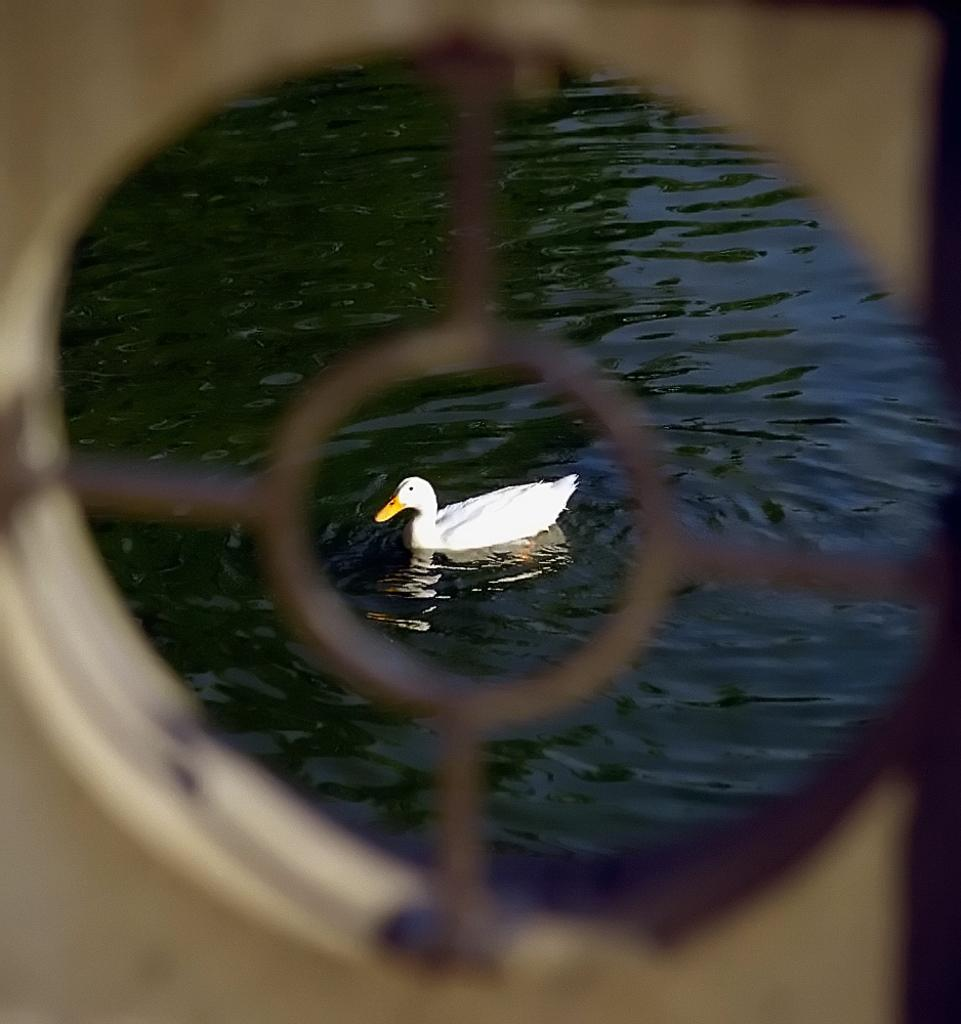What type of animal is in the image? There is a white duck in the image. Where is the duck located? The duck is on the water. What type of road is visible in the image? There is no road visible in the image; it features a white duck on the water. What type of meat is being prepared in the image? There is no meat preparation visible in the image; it features a white duck on the water. 